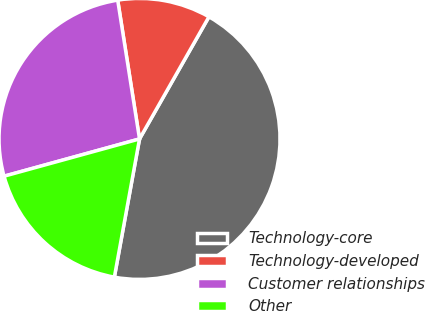Convert chart to OTSL. <chart><loc_0><loc_0><loc_500><loc_500><pie_chart><fcel>Technology-core<fcel>Technology-developed<fcel>Customer relationships<fcel>Other<nl><fcel>44.64%<fcel>10.71%<fcel>26.79%<fcel>17.86%<nl></chart> 